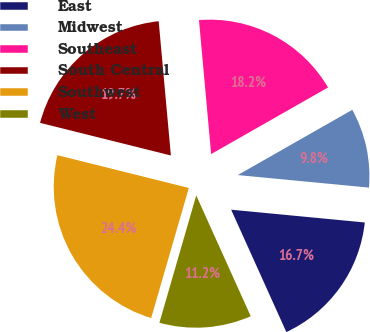<chart> <loc_0><loc_0><loc_500><loc_500><pie_chart><fcel>East<fcel>Midwest<fcel>Southeast<fcel>South Central<fcel>Southwest<fcel>West<nl><fcel>16.74%<fcel>9.76%<fcel>18.2%<fcel>19.67%<fcel>24.41%<fcel>11.23%<nl></chart> 